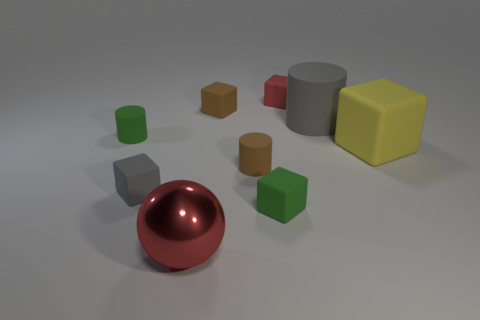Can you describe the different shapes present in the image? Certainly! The image exhibits a collection of geometric shapes: there are cylinders, spheres, and cubes. Among them, the sphere showcases a reflective surface, distinguishing it from the more subdued appearance of the cubes and cylinders. Which shape seems to be the most prominent? The sphere stands out the most due to its reflective, shiny surface and the fact that it's centrally placed in the image, which draws the viewer's eye. 